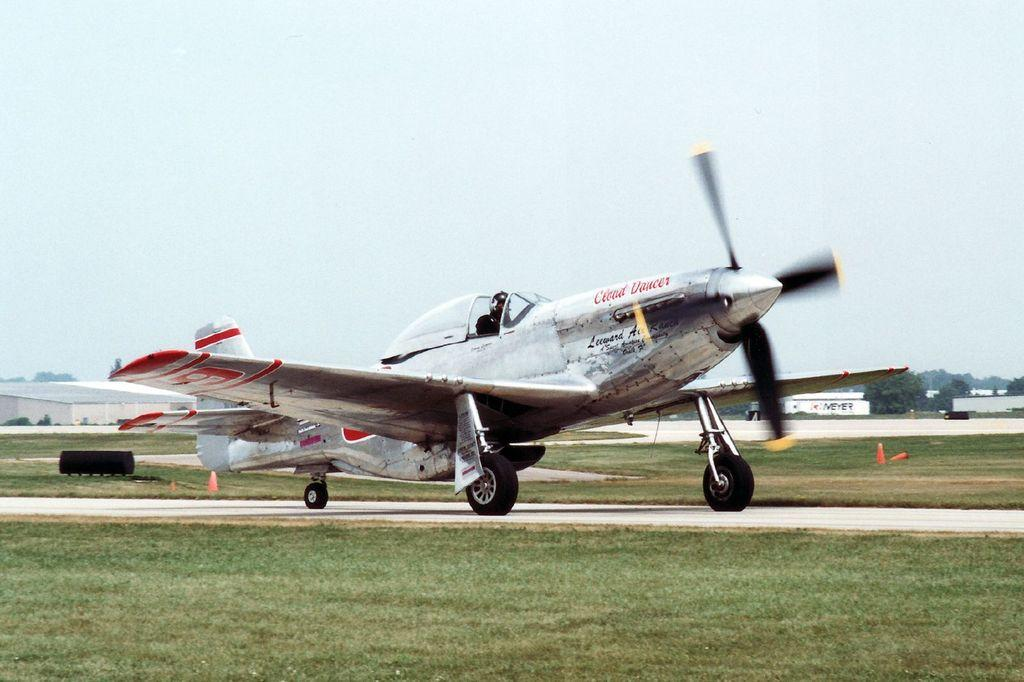What is located on the runway in the image? There is an aircraft on the runway in the image. What type of vegetation can be seen in the image? There is grass visible in the image. What safety feature is present in the image? Traffic cones are present in the image. What color can be observed in the image? There are black color objects in the image. What structures are visible in the background of the image? There are houses in the background of the image. What natural elements are visible in the background of the image? Trees and the sky are visible in the background of the image. How many pizzas are being served by the team in the image? There are no pizzas or teams present in the image; it features an aircraft on a runway with grass, traffic cones, black color objects, houses, trees, and the sky in the background. What type of cactus can be seen growing near the aircraft in the image? There is no cactus present in the image; it features an aircraft on a runway with grass, traffic cones, black color objects, houses, trees, and the sky in the background. 